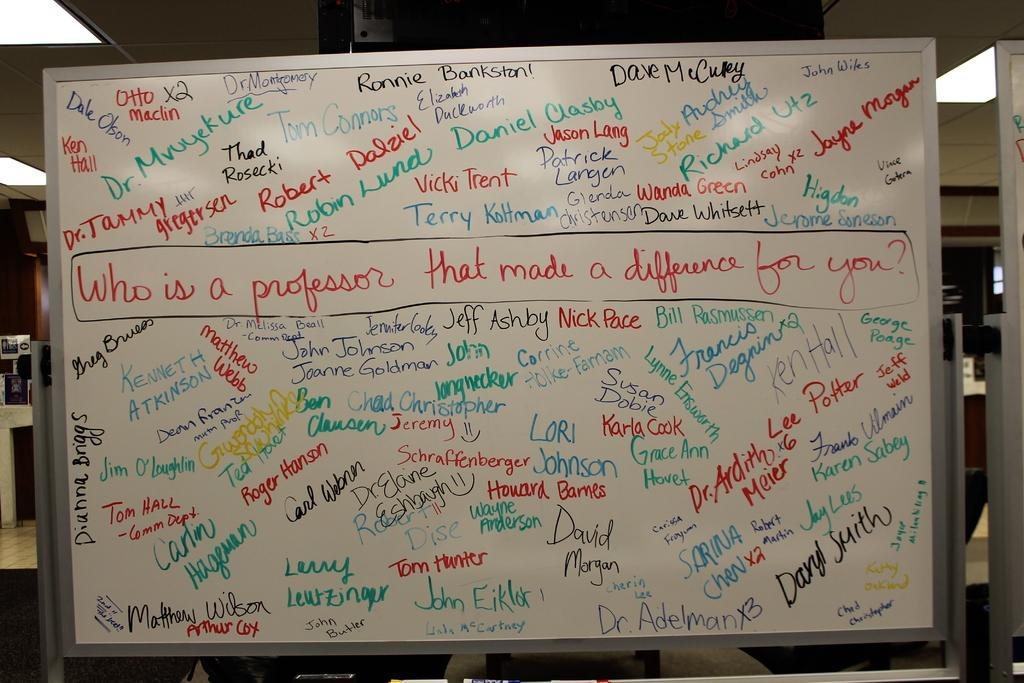What is written on the board in the image? There is text written on a board in the image. Where else can text be found in the image? There is text written on the ceiling in the image. How many ladybugs can be seen on the island in the image? There is no island or ladybugs present in the image. What type of toys are scattered around the room in the image? There is no mention of toys in the provided facts, so we cannot answer this question. 